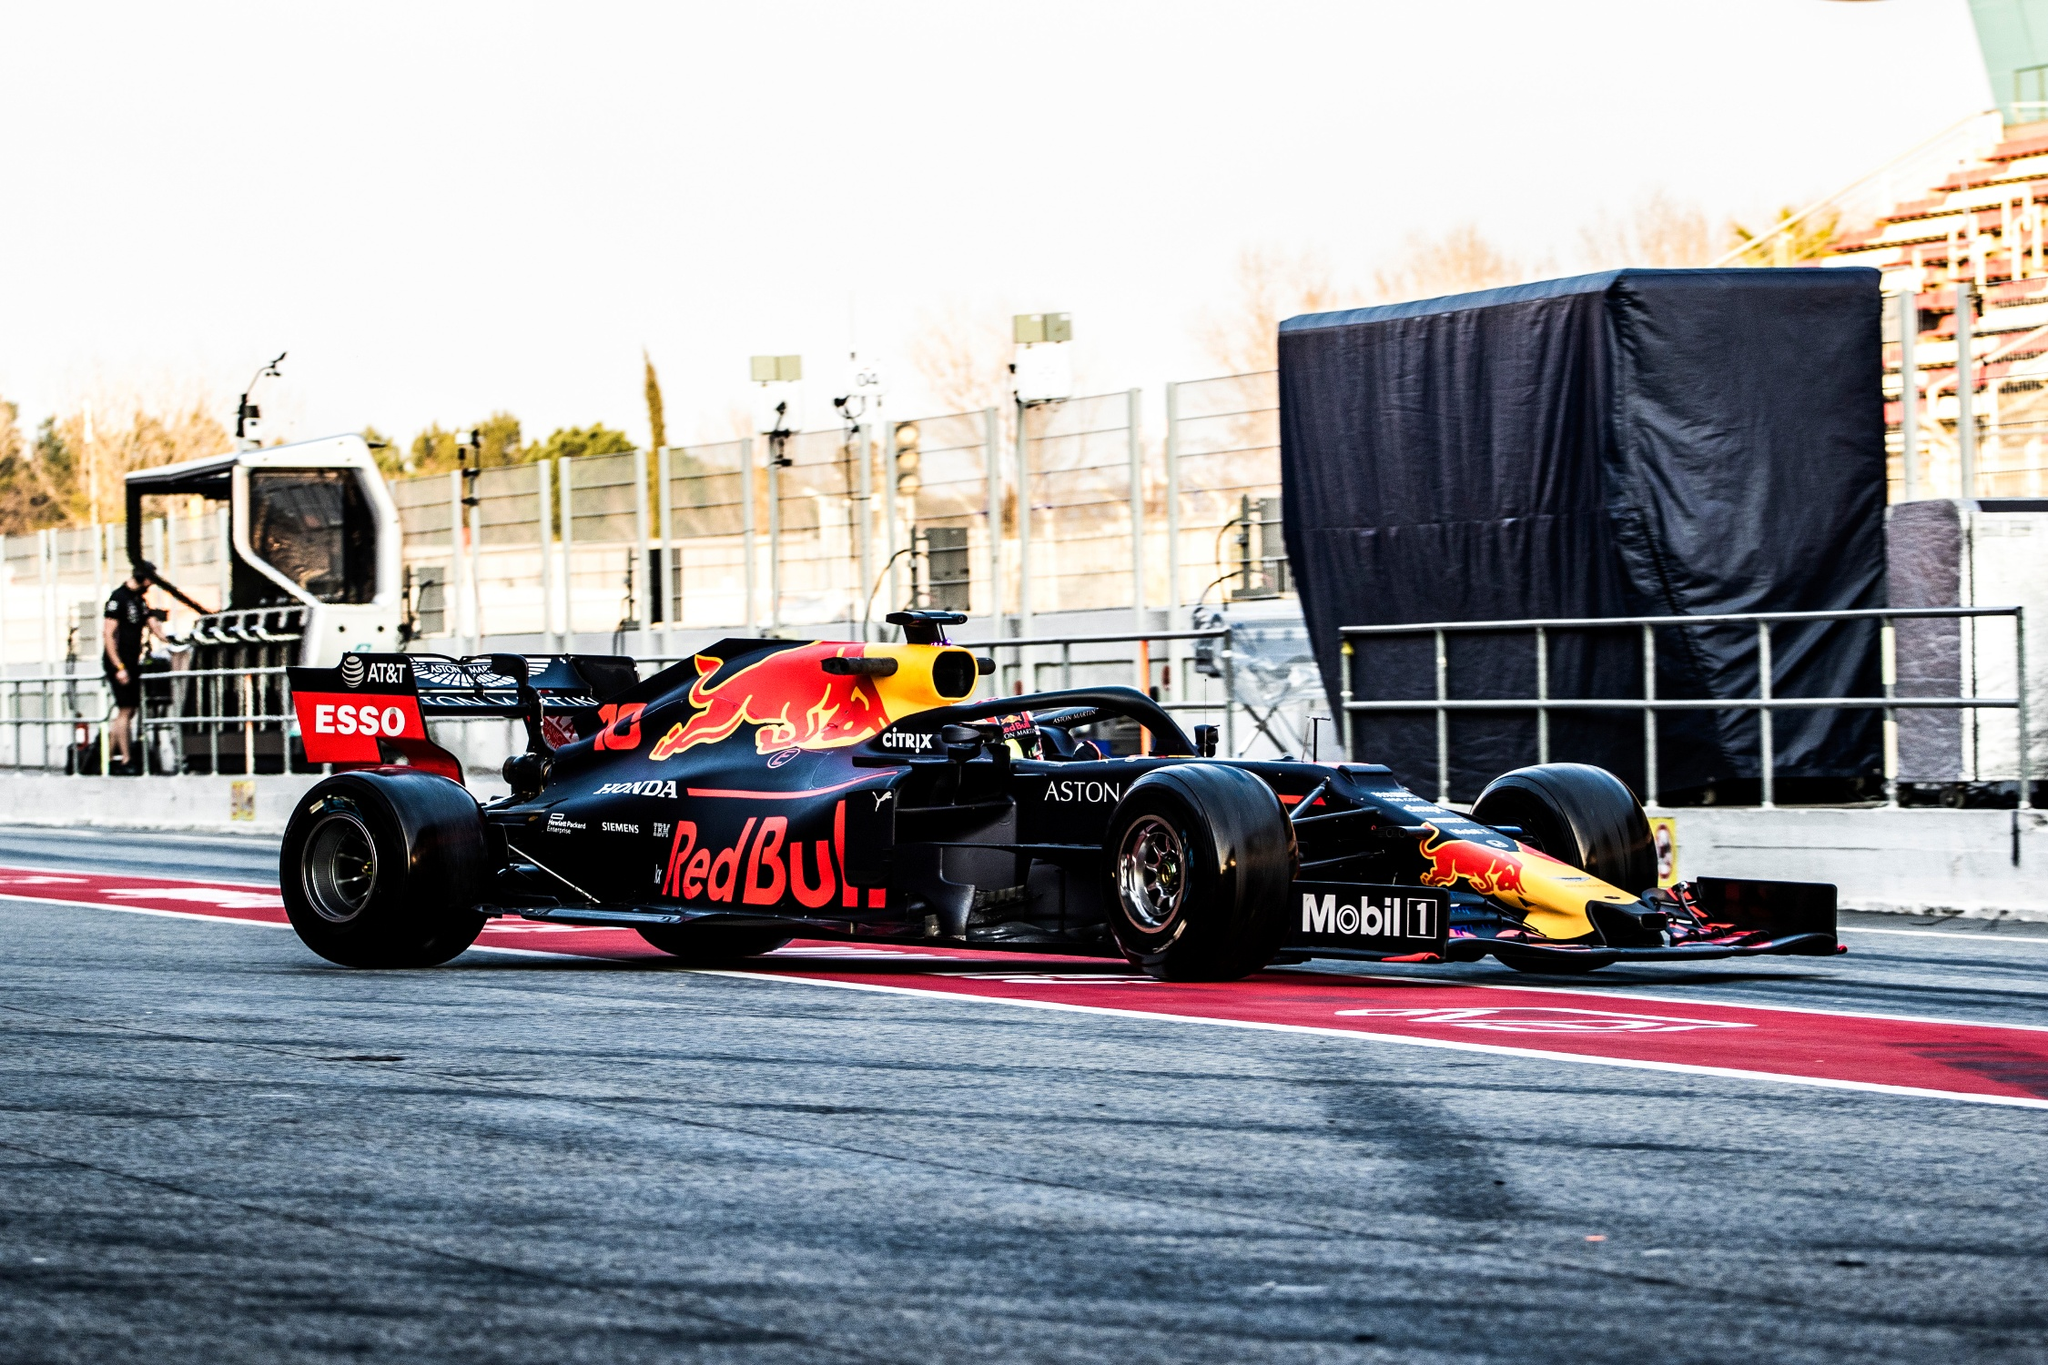Could you create a short story involving the race car as the protagonist? Once upon a time, in the world of high-speed competition, there existed a Red Bull Formula One car named Blitz. Born out of cutting-edge technology and engineering marvel, Blitz was not just any race car but a legend in the making. With each race, Blitz's fame grew as it showcased unparalleled speed and agility on tracks around the world.

Blitz had a unique bond with its driver, Max. Together, they were a formidable team, communicating through twists and turns, pushing boundaries with every race. One day, during the prestigious Monaco Grand Prix, Blitz faced its greatest challenge. A sudden downpour had made the track treacherously slick. Other racers faltered, but Max and Blitz saw this as an opportunity to shine.

With perfect harmony and unyielding determination, they navigated the perilous bends of Monte Carlo. Tire smoke mingled with the rain as Blitz's tires gripped the slick track with precision. Spectators watched in awe as Blitz and Max overcame the daunting conditions. In the final lap, under the roaring cheers of the crowd, Blitz crossed the finish line first, marking a heroic victory.

From that day on, Blitz was not just known for its speed but also its heart, symbolizing the undying spirit of racing and the incredible bond between man and machine. 